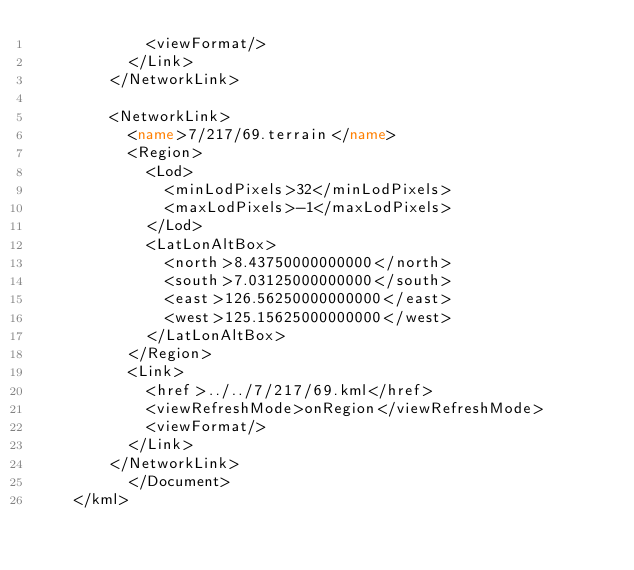Convert code to text. <code><loc_0><loc_0><loc_500><loc_500><_XML_>	        <viewFormat/>
	      </Link>
	    </NetworkLink>
	
	    <NetworkLink>
	      <name>7/217/69.terrain</name>
	      <Region>
	        <Lod>
	          <minLodPixels>32</minLodPixels>
	          <maxLodPixels>-1</maxLodPixels>
	        </Lod>
	        <LatLonAltBox>
	          <north>8.43750000000000</north>
	          <south>7.03125000000000</south>
	          <east>126.56250000000000</east>
	          <west>125.15625000000000</west>
	        </LatLonAltBox>
	      </Region>
	      <Link>
	        <href>../../7/217/69.kml</href>
	        <viewRefreshMode>onRegion</viewRefreshMode>
	        <viewFormat/>
	      </Link>
	    </NetworkLink>
		  </Document>
	</kml>
	</code> 